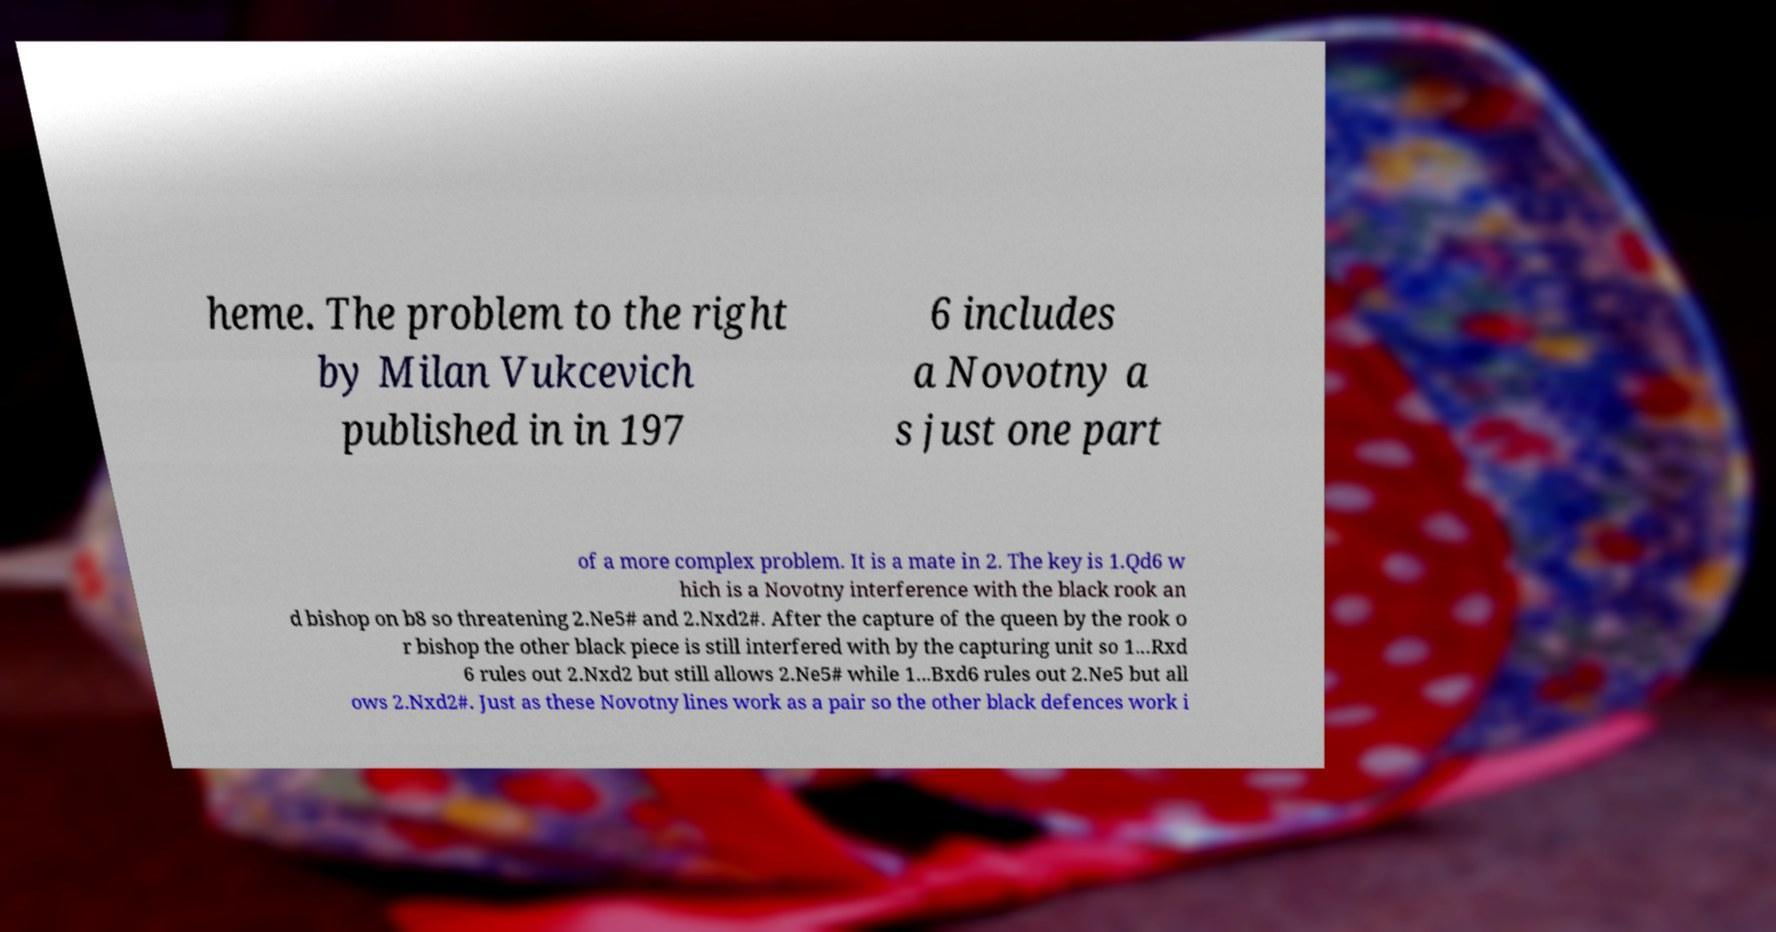For documentation purposes, I need the text within this image transcribed. Could you provide that? heme. The problem to the right by Milan Vukcevich published in in 197 6 includes a Novotny a s just one part of a more complex problem. It is a mate in 2. The key is 1.Qd6 w hich is a Novotny interference with the black rook an d bishop on b8 so threatening 2.Ne5# and 2.Nxd2#. After the capture of the queen by the rook o r bishop the other black piece is still interfered with by the capturing unit so 1...Rxd 6 rules out 2.Nxd2 but still allows 2.Ne5# while 1...Bxd6 rules out 2.Ne5 but all ows 2.Nxd2#. Just as these Novotny lines work as a pair so the other black defences work i 